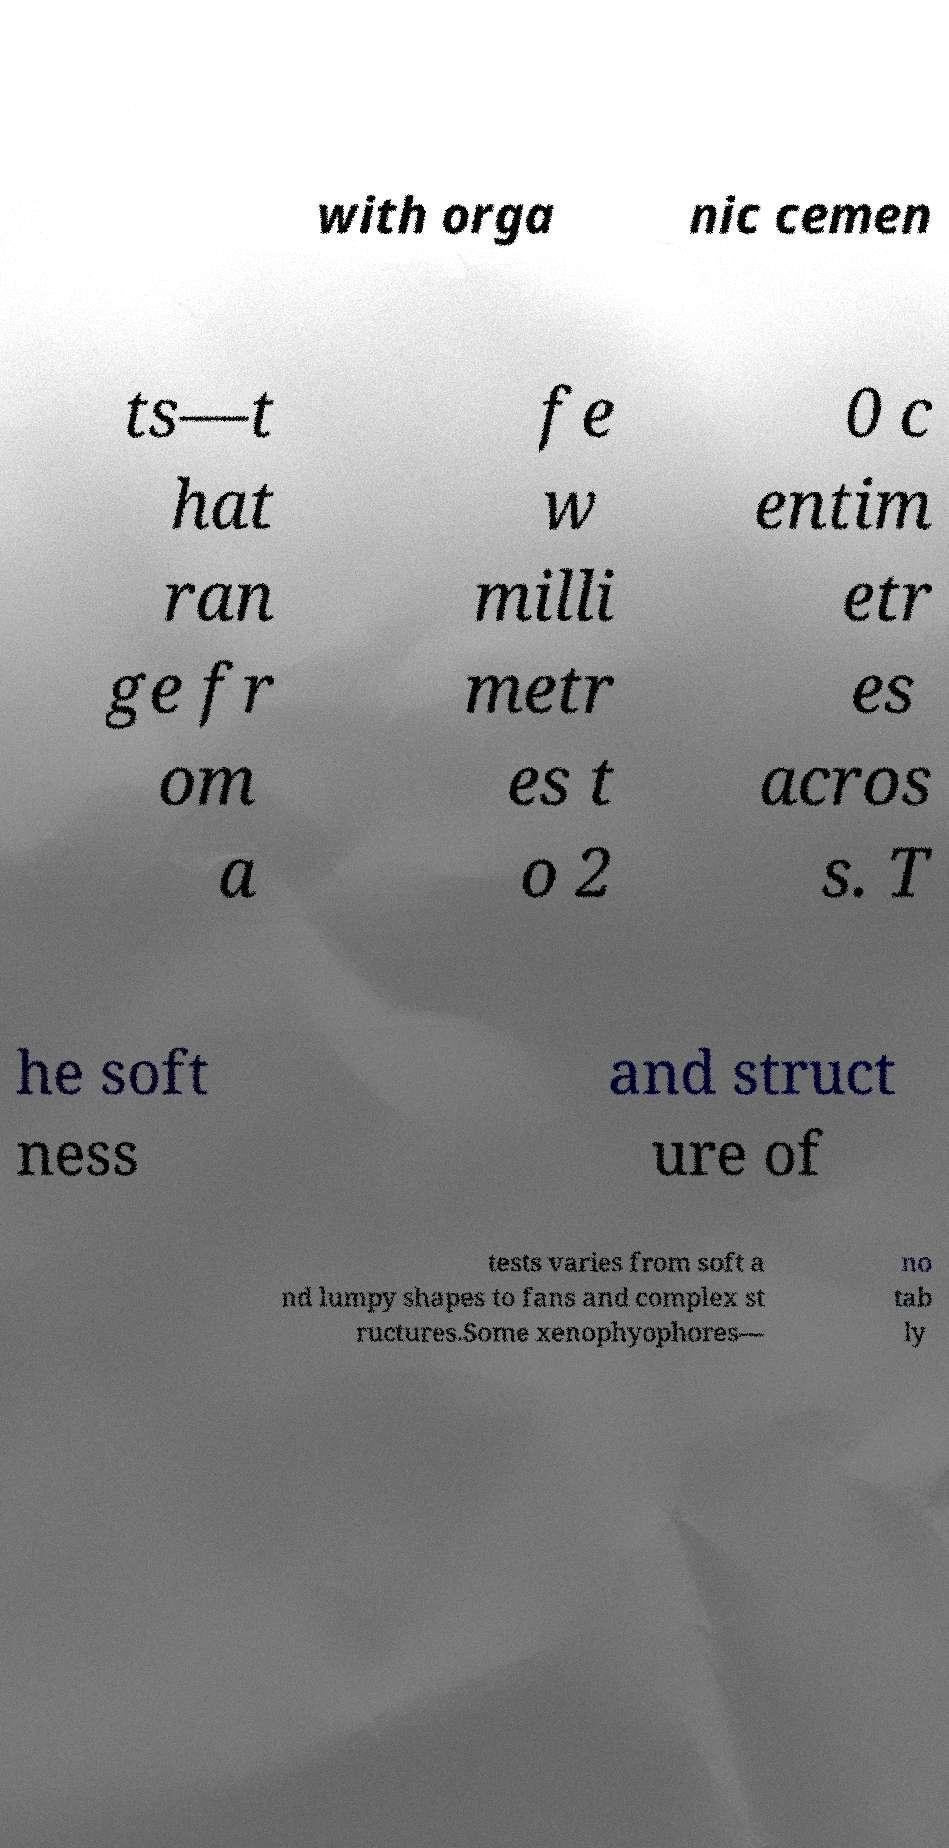What messages or text are displayed in this image? I need them in a readable, typed format. with orga nic cemen ts—t hat ran ge fr om a fe w milli metr es t o 2 0 c entim etr es acros s. T he soft ness and struct ure of tests varies from soft a nd lumpy shapes to fans and complex st ructures.Some xenophyophores— no tab ly 